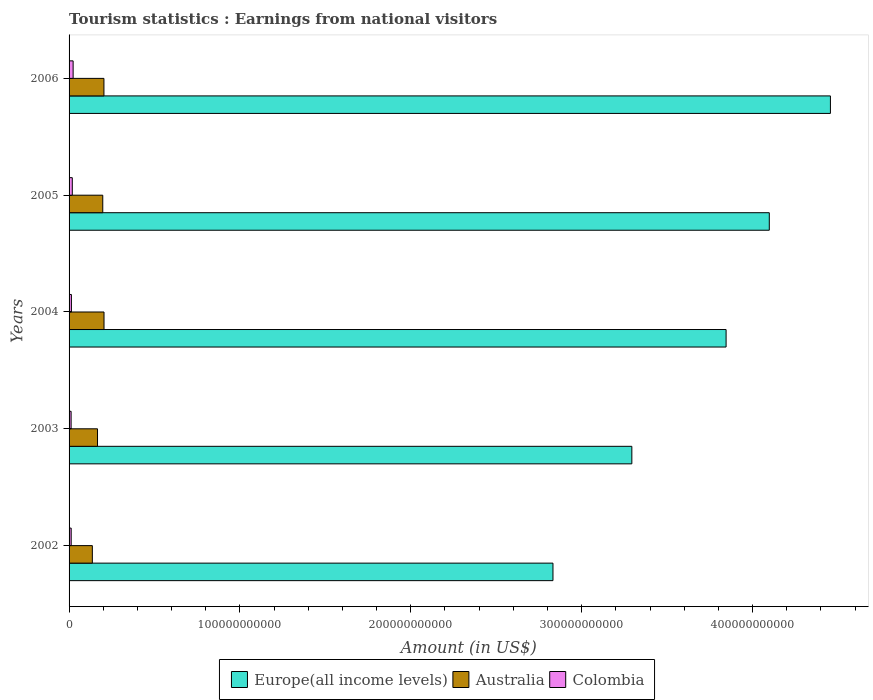How many groups of bars are there?
Make the answer very short. 5. Are the number of bars per tick equal to the number of legend labels?
Your answer should be compact. Yes. Are the number of bars on each tick of the Y-axis equal?
Your answer should be compact. Yes. How many bars are there on the 2nd tick from the top?
Provide a succinct answer. 3. What is the label of the 3rd group of bars from the top?
Provide a succinct answer. 2004. What is the earnings from national visitors in Colombia in 2004?
Make the answer very short. 1.37e+09. Across all years, what is the maximum earnings from national visitors in Australia?
Offer a terse response. 2.05e+1. Across all years, what is the minimum earnings from national visitors in Australia?
Make the answer very short. 1.36e+1. In which year was the earnings from national visitors in Colombia maximum?
Make the answer very short. 2006. What is the total earnings from national visitors in Colombia in the graph?
Your answer should be compact. 8.06e+09. What is the difference between the earnings from national visitors in Europe(all income levels) in 2004 and that in 2006?
Your answer should be very brief. -6.11e+1. What is the difference between the earnings from national visitors in Australia in 2006 and the earnings from national visitors in Colombia in 2003?
Offer a very short reply. 1.92e+1. What is the average earnings from national visitors in Australia per year?
Provide a short and direct response. 1.82e+1. In the year 2005, what is the difference between the earnings from national visitors in Europe(all income levels) and earnings from national visitors in Colombia?
Make the answer very short. 4.08e+11. In how many years, is the earnings from national visitors in Colombia greater than 220000000000 US$?
Your answer should be compact. 0. What is the ratio of the earnings from national visitors in Colombia in 2004 to that in 2006?
Your answer should be compact. 0.58. Is the difference between the earnings from national visitors in Europe(all income levels) in 2004 and 2005 greater than the difference between the earnings from national visitors in Colombia in 2004 and 2005?
Provide a short and direct response. No. What is the difference between the highest and the second highest earnings from national visitors in Australia?
Provide a succinct answer. 4.50e+07. What is the difference between the highest and the lowest earnings from national visitors in Europe(all income levels)?
Offer a terse response. 1.62e+11. Is the sum of the earnings from national visitors in Australia in 2003 and 2005 greater than the maximum earnings from national visitors in Colombia across all years?
Give a very brief answer. Yes. What does the 3rd bar from the top in 2004 represents?
Provide a short and direct response. Europe(all income levels). What does the 3rd bar from the bottom in 2006 represents?
Ensure brevity in your answer.  Colombia. How many bars are there?
Your answer should be very brief. 15. Are all the bars in the graph horizontal?
Make the answer very short. Yes. How many years are there in the graph?
Ensure brevity in your answer.  5. What is the difference between two consecutive major ticks on the X-axis?
Provide a succinct answer. 1.00e+11. Are the values on the major ticks of X-axis written in scientific E-notation?
Provide a succinct answer. No. How many legend labels are there?
Provide a short and direct response. 3. What is the title of the graph?
Provide a short and direct response. Tourism statistics : Earnings from national visitors. Does "Venezuela" appear as one of the legend labels in the graph?
Keep it short and to the point. No. What is the label or title of the X-axis?
Provide a succinct answer. Amount (in US$). What is the Amount (in US$) of Europe(all income levels) in 2002?
Offer a very short reply. 2.83e+11. What is the Amount (in US$) of Australia in 2002?
Offer a very short reply. 1.36e+1. What is the Amount (in US$) in Colombia in 2002?
Offer a very short reply. 1.24e+09. What is the Amount (in US$) in Europe(all income levels) in 2003?
Your answer should be compact. 3.29e+11. What is the Amount (in US$) in Australia in 2003?
Your answer should be compact. 1.66e+1. What is the Amount (in US$) of Colombia in 2003?
Your answer should be compact. 1.19e+09. What is the Amount (in US$) in Europe(all income levels) in 2004?
Provide a succinct answer. 3.85e+11. What is the Amount (in US$) in Australia in 2004?
Make the answer very short. 2.05e+1. What is the Amount (in US$) of Colombia in 2004?
Provide a short and direct response. 1.37e+09. What is the Amount (in US$) in Europe(all income levels) in 2005?
Give a very brief answer. 4.10e+11. What is the Amount (in US$) in Australia in 2005?
Provide a short and direct response. 1.97e+1. What is the Amount (in US$) in Colombia in 2005?
Your response must be concise. 1.89e+09. What is the Amount (in US$) of Europe(all income levels) in 2006?
Provide a succinct answer. 4.46e+11. What is the Amount (in US$) in Australia in 2006?
Keep it short and to the point. 2.04e+1. What is the Amount (in US$) in Colombia in 2006?
Your answer should be very brief. 2.37e+09. Across all years, what is the maximum Amount (in US$) in Europe(all income levels)?
Your response must be concise. 4.46e+11. Across all years, what is the maximum Amount (in US$) of Australia?
Your response must be concise. 2.05e+1. Across all years, what is the maximum Amount (in US$) in Colombia?
Keep it short and to the point. 2.37e+09. Across all years, what is the minimum Amount (in US$) in Europe(all income levels)?
Provide a succinct answer. 2.83e+11. Across all years, what is the minimum Amount (in US$) of Australia?
Provide a short and direct response. 1.36e+1. Across all years, what is the minimum Amount (in US$) of Colombia?
Provide a short and direct response. 1.19e+09. What is the total Amount (in US$) of Europe(all income levels) in the graph?
Provide a succinct answer. 1.85e+12. What is the total Amount (in US$) in Australia in the graph?
Your answer should be compact. 9.09e+1. What is the total Amount (in US$) in Colombia in the graph?
Make the answer very short. 8.06e+09. What is the difference between the Amount (in US$) of Europe(all income levels) in 2002 and that in 2003?
Offer a very short reply. -4.62e+1. What is the difference between the Amount (in US$) in Australia in 2002 and that in 2003?
Provide a short and direct response. -3.02e+09. What is the difference between the Amount (in US$) in Colombia in 2002 and that in 2003?
Ensure brevity in your answer.  4.60e+07. What is the difference between the Amount (in US$) in Europe(all income levels) in 2002 and that in 2004?
Offer a terse response. -1.01e+11. What is the difference between the Amount (in US$) of Australia in 2002 and that in 2004?
Your answer should be very brief. -6.83e+09. What is the difference between the Amount (in US$) in Colombia in 2002 and that in 2004?
Provide a short and direct response. -1.32e+08. What is the difference between the Amount (in US$) in Europe(all income levels) in 2002 and that in 2005?
Keep it short and to the point. -1.27e+11. What is the difference between the Amount (in US$) of Australia in 2002 and that in 2005?
Make the answer very short. -6.10e+09. What is the difference between the Amount (in US$) in Colombia in 2002 and that in 2005?
Your answer should be compact. -6.54e+08. What is the difference between the Amount (in US$) in Europe(all income levels) in 2002 and that in 2006?
Provide a succinct answer. -1.62e+11. What is the difference between the Amount (in US$) in Australia in 2002 and that in 2006?
Offer a terse response. -6.78e+09. What is the difference between the Amount (in US$) of Colombia in 2002 and that in 2006?
Keep it short and to the point. -1.13e+09. What is the difference between the Amount (in US$) in Europe(all income levels) in 2003 and that in 2004?
Provide a succinct answer. -5.52e+1. What is the difference between the Amount (in US$) in Australia in 2003 and that in 2004?
Make the answer very short. -3.81e+09. What is the difference between the Amount (in US$) of Colombia in 2003 and that in 2004?
Offer a very short reply. -1.78e+08. What is the difference between the Amount (in US$) of Europe(all income levels) in 2003 and that in 2005?
Provide a short and direct response. -8.04e+1. What is the difference between the Amount (in US$) of Australia in 2003 and that in 2005?
Give a very brief answer. -3.07e+09. What is the difference between the Amount (in US$) of Colombia in 2003 and that in 2005?
Keep it short and to the point. -7.00e+08. What is the difference between the Amount (in US$) in Europe(all income levels) in 2003 and that in 2006?
Your response must be concise. -1.16e+11. What is the difference between the Amount (in US$) in Australia in 2003 and that in 2006?
Your answer should be compact. -3.76e+09. What is the difference between the Amount (in US$) in Colombia in 2003 and that in 2006?
Your answer should be compact. -1.18e+09. What is the difference between the Amount (in US$) in Europe(all income levels) in 2004 and that in 2005?
Your answer should be very brief. -2.53e+1. What is the difference between the Amount (in US$) in Australia in 2004 and that in 2005?
Provide a succinct answer. 7.34e+08. What is the difference between the Amount (in US$) in Colombia in 2004 and that in 2005?
Offer a very short reply. -5.22e+08. What is the difference between the Amount (in US$) of Europe(all income levels) in 2004 and that in 2006?
Provide a succinct answer. -6.11e+1. What is the difference between the Amount (in US$) in Australia in 2004 and that in 2006?
Make the answer very short. 4.50e+07. What is the difference between the Amount (in US$) of Colombia in 2004 and that in 2006?
Your answer should be very brief. -1.00e+09. What is the difference between the Amount (in US$) of Europe(all income levels) in 2005 and that in 2006?
Keep it short and to the point. -3.58e+1. What is the difference between the Amount (in US$) in Australia in 2005 and that in 2006?
Your answer should be very brief. -6.89e+08. What is the difference between the Amount (in US$) in Colombia in 2005 and that in 2006?
Your answer should be compact. -4.79e+08. What is the difference between the Amount (in US$) of Europe(all income levels) in 2002 and the Amount (in US$) of Australia in 2003?
Offer a terse response. 2.67e+11. What is the difference between the Amount (in US$) of Europe(all income levels) in 2002 and the Amount (in US$) of Colombia in 2003?
Keep it short and to the point. 2.82e+11. What is the difference between the Amount (in US$) in Australia in 2002 and the Amount (in US$) in Colombia in 2003?
Keep it short and to the point. 1.24e+1. What is the difference between the Amount (in US$) of Europe(all income levels) in 2002 and the Amount (in US$) of Australia in 2004?
Offer a very short reply. 2.63e+11. What is the difference between the Amount (in US$) of Europe(all income levels) in 2002 and the Amount (in US$) of Colombia in 2004?
Your response must be concise. 2.82e+11. What is the difference between the Amount (in US$) in Australia in 2002 and the Amount (in US$) in Colombia in 2004?
Provide a succinct answer. 1.23e+1. What is the difference between the Amount (in US$) in Europe(all income levels) in 2002 and the Amount (in US$) in Australia in 2005?
Keep it short and to the point. 2.63e+11. What is the difference between the Amount (in US$) of Europe(all income levels) in 2002 and the Amount (in US$) of Colombia in 2005?
Keep it short and to the point. 2.81e+11. What is the difference between the Amount (in US$) of Australia in 2002 and the Amount (in US$) of Colombia in 2005?
Give a very brief answer. 1.17e+1. What is the difference between the Amount (in US$) of Europe(all income levels) in 2002 and the Amount (in US$) of Australia in 2006?
Your answer should be very brief. 2.63e+11. What is the difference between the Amount (in US$) of Europe(all income levels) in 2002 and the Amount (in US$) of Colombia in 2006?
Offer a terse response. 2.81e+11. What is the difference between the Amount (in US$) of Australia in 2002 and the Amount (in US$) of Colombia in 2006?
Provide a short and direct response. 1.13e+1. What is the difference between the Amount (in US$) of Europe(all income levels) in 2003 and the Amount (in US$) of Australia in 2004?
Ensure brevity in your answer.  3.09e+11. What is the difference between the Amount (in US$) of Europe(all income levels) in 2003 and the Amount (in US$) of Colombia in 2004?
Provide a short and direct response. 3.28e+11. What is the difference between the Amount (in US$) of Australia in 2003 and the Amount (in US$) of Colombia in 2004?
Provide a succinct answer. 1.53e+1. What is the difference between the Amount (in US$) of Europe(all income levels) in 2003 and the Amount (in US$) of Australia in 2005?
Provide a short and direct response. 3.10e+11. What is the difference between the Amount (in US$) in Europe(all income levels) in 2003 and the Amount (in US$) in Colombia in 2005?
Provide a succinct answer. 3.27e+11. What is the difference between the Amount (in US$) of Australia in 2003 and the Amount (in US$) of Colombia in 2005?
Offer a very short reply. 1.48e+1. What is the difference between the Amount (in US$) of Europe(all income levels) in 2003 and the Amount (in US$) of Australia in 2006?
Keep it short and to the point. 3.09e+11. What is the difference between the Amount (in US$) of Europe(all income levels) in 2003 and the Amount (in US$) of Colombia in 2006?
Provide a succinct answer. 3.27e+11. What is the difference between the Amount (in US$) of Australia in 2003 and the Amount (in US$) of Colombia in 2006?
Your response must be concise. 1.43e+1. What is the difference between the Amount (in US$) in Europe(all income levels) in 2004 and the Amount (in US$) in Australia in 2005?
Give a very brief answer. 3.65e+11. What is the difference between the Amount (in US$) of Europe(all income levels) in 2004 and the Amount (in US$) of Colombia in 2005?
Give a very brief answer. 3.83e+11. What is the difference between the Amount (in US$) in Australia in 2004 and the Amount (in US$) in Colombia in 2005?
Your answer should be very brief. 1.86e+1. What is the difference between the Amount (in US$) of Europe(all income levels) in 2004 and the Amount (in US$) of Australia in 2006?
Your response must be concise. 3.64e+11. What is the difference between the Amount (in US$) of Europe(all income levels) in 2004 and the Amount (in US$) of Colombia in 2006?
Make the answer very short. 3.82e+11. What is the difference between the Amount (in US$) of Australia in 2004 and the Amount (in US$) of Colombia in 2006?
Your response must be concise. 1.81e+1. What is the difference between the Amount (in US$) in Europe(all income levels) in 2005 and the Amount (in US$) in Australia in 2006?
Your answer should be very brief. 3.89e+11. What is the difference between the Amount (in US$) of Europe(all income levels) in 2005 and the Amount (in US$) of Colombia in 2006?
Ensure brevity in your answer.  4.07e+11. What is the difference between the Amount (in US$) of Australia in 2005 and the Amount (in US$) of Colombia in 2006?
Offer a terse response. 1.73e+1. What is the average Amount (in US$) in Europe(all income levels) per year?
Make the answer very short. 3.71e+11. What is the average Amount (in US$) of Australia per year?
Your response must be concise. 1.82e+1. What is the average Amount (in US$) in Colombia per year?
Your response must be concise. 1.61e+09. In the year 2002, what is the difference between the Amount (in US$) in Europe(all income levels) and Amount (in US$) in Australia?
Offer a very short reply. 2.70e+11. In the year 2002, what is the difference between the Amount (in US$) in Europe(all income levels) and Amount (in US$) in Colombia?
Your answer should be compact. 2.82e+11. In the year 2002, what is the difference between the Amount (in US$) of Australia and Amount (in US$) of Colombia?
Provide a succinct answer. 1.24e+1. In the year 2003, what is the difference between the Amount (in US$) in Europe(all income levels) and Amount (in US$) in Australia?
Provide a short and direct response. 3.13e+11. In the year 2003, what is the difference between the Amount (in US$) in Europe(all income levels) and Amount (in US$) in Colombia?
Make the answer very short. 3.28e+11. In the year 2003, what is the difference between the Amount (in US$) in Australia and Amount (in US$) in Colombia?
Provide a short and direct response. 1.55e+1. In the year 2004, what is the difference between the Amount (in US$) in Europe(all income levels) and Amount (in US$) in Australia?
Give a very brief answer. 3.64e+11. In the year 2004, what is the difference between the Amount (in US$) of Europe(all income levels) and Amount (in US$) of Colombia?
Your answer should be compact. 3.83e+11. In the year 2004, what is the difference between the Amount (in US$) of Australia and Amount (in US$) of Colombia?
Give a very brief answer. 1.91e+1. In the year 2005, what is the difference between the Amount (in US$) in Europe(all income levels) and Amount (in US$) in Australia?
Make the answer very short. 3.90e+11. In the year 2005, what is the difference between the Amount (in US$) in Europe(all income levels) and Amount (in US$) in Colombia?
Make the answer very short. 4.08e+11. In the year 2005, what is the difference between the Amount (in US$) of Australia and Amount (in US$) of Colombia?
Provide a succinct answer. 1.78e+1. In the year 2006, what is the difference between the Amount (in US$) in Europe(all income levels) and Amount (in US$) in Australia?
Your answer should be very brief. 4.25e+11. In the year 2006, what is the difference between the Amount (in US$) of Europe(all income levels) and Amount (in US$) of Colombia?
Your answer should be compact. 4.43e+11. In the year 2006, what is the difference between the Amount (in US$) in Australia and Amount (in US$) in Colombia?
Your answer should be compact. 1.80e+1. What is the ratio of the Amount (in US$) in Europe(all income levels) in 2002 to that in 2003?
Ensure brevity in your answer.  0.86. What is the ratio of the Amount (in US$) of Australia in 2002 to that in 2003?
Give a very brief answer. 0.82. What is the ratio of the Amount (in US$) in Colombia in 2002 to that in 2003?
Your response must be concise. 1.04. What is the ratio of the Amount (in US$) of Europe(all income levels) in 2002 to that in 2004?
Ensure brevity in your answer.  0.74. What is the ratio of the Amount (in US$) in Australia in 2002 to that in 2004?
Your answer should be compact. 0.67. What is the ratio of the Amount (in US$) of Colombia in 2002 to that in 2004?
Offer a very short reply. 0.9. What is the ratio of the Amount (in US$) in Europe(all income levels) in 2002 to that in 2005?
Your answer should be compact. 0.69. What is the ratio of the Amount (in US$) of Australia in 2002 to that in 2005?
Offer a terse response. 0.69. What is the ratio of the Amount (in US$) in Colombia in 2002 to that in 2005?
Keep it short and to the point. 0.65. What is the ratio of the Amount (in US$) in Europe(all income levels) in 2002 to that in 2006?
Keep it short and to the point. 0.64. What is the ratio of the Amount (in US$) of Australia in 2002 to that in 2006?
Give a very brief answer. 0.67. What is the ratio of the Amount (in US$) in Colombia in 2002 to that in 2006?
Provide a short and direct response. 0.52. What is the ratio of the Amount (in US$) in Europe(all income levels) in 2003 to that in 2004?
Your answer should be very brief. 0.86. What is the ratio of the Amount (in US$) of Australia in 2003 to that in 2004?
Your response must be concise. 0.81. What is the ratio of the Amount (in US$) in Colombia in 2003 to that in 2004?
Offer a very short reply. 0.87. What is the ratio of the Amount (in US$) in Europe(all income levels) in 2003 to that in 2005?
Offer a very short reply. 0.8. What is the ratio of the Amount (in US$) of Australia in 2003 to that in 2005?
Give a very brief answer. 0.84. What is the ratio of the Amount (in US$) in Colombia in 2003 to that in 2005?
Your response must be concise. 0.63. What is the ratio of the Amount (in US$) of Europe(all income levels) in 2003 to that in 2006?
Give a very brief answer. 0.74. What is the ratio of the Amount (in US$) in Australia in 2003 to that in 2006?
Keep it short and to the point. 0.82. What is the ratio of the Amount (in US$) of Colombia in 2003 to that in 2006?
Provide a short and direct response. 0.5. What is the ratio of the Amount (in US$) in Europe(all income levels) in 2004 to that in 2005?
Provide a short and direct response. 0.94. What is the ratio of the Amount (in US$) in Australia in 2004 to that in 2005?
Make the answer very short. 1.04. What is the ratio of the Amount (in US$) of Colombia in 2004 to that in 2005?
Your response must be concise. 0.72. What is the ratio of the Amount (in US$) in Europe(all income levels) in 2004 to that in 2006?
Your answer should be very brief. 0.86. What is the ratio of the Amount (in US$) of Colombia in 2004 to that in 2006?
Make the answer very short. 0.58. What is the ratio of the Amount (in US$) of Europe(all income levels) in 2005 to that in 2006?
Offer a terse response. 0.92. What is the ratio of the Amount (in US$) in Australia in 2005 to that in 2006?
Provide a succinct answer. 0.97. What is the ratio of the Amount (in US$) of Colombia in 2005 to that in 2006?
Your answer should be very brief. 0.8. What is the difference between the highest and the second highest Amount (in US$) of Europe(all income levels)?
Ensure brevity in your answer.  3.58e+1. What is the difference between the highest and the second highest Amount (in US$) in Australia?
Your answer should be very brief. 4.50e+07. What is the difference between the highest and the second highest Amount (in US$) of Colombia?
Your answer should be compact. 4.79e+08. What is the difference between the highest and the lowest Amount (in US$) in Europe(all income levels)?
Provide a succinct answer. 1.62e+11. What is the difference between the highest and the lowest Amount (in US$) in Australia?
Ensure brevity in your answer.  6.83e+09. What is the difference between the highest and the lowest Amount (in US$) of Colombia?
Ensure brevity in your answer.  1.18e+09. 